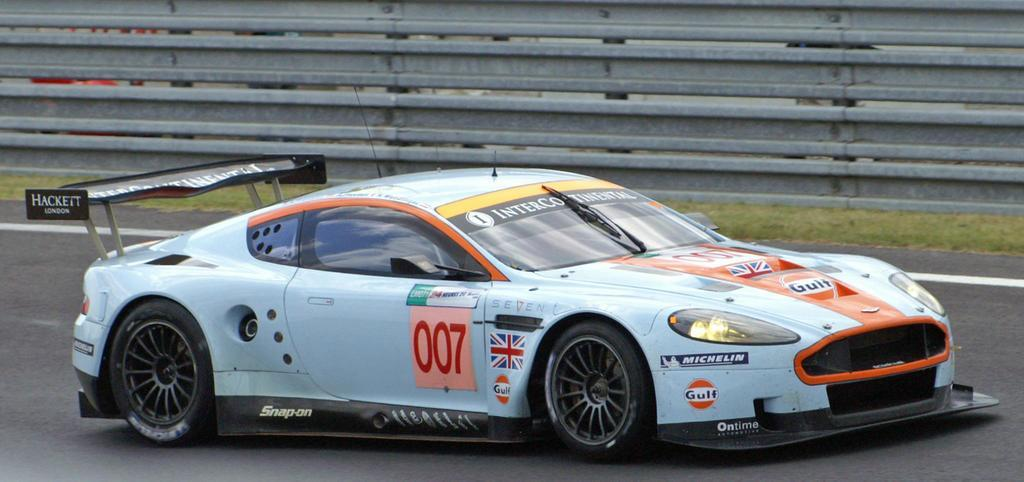What is the main subject of the image? There is a vehicle on the road in the image. What type of natural environment can be seen in the image? There is grass visible in the image. What is the background of the image composed of? The background appears to be a fence. What type of boats can be seen sailing in the image? There are no boats present in the image; it features a vehicle on the road with grass and a fence in the background. 